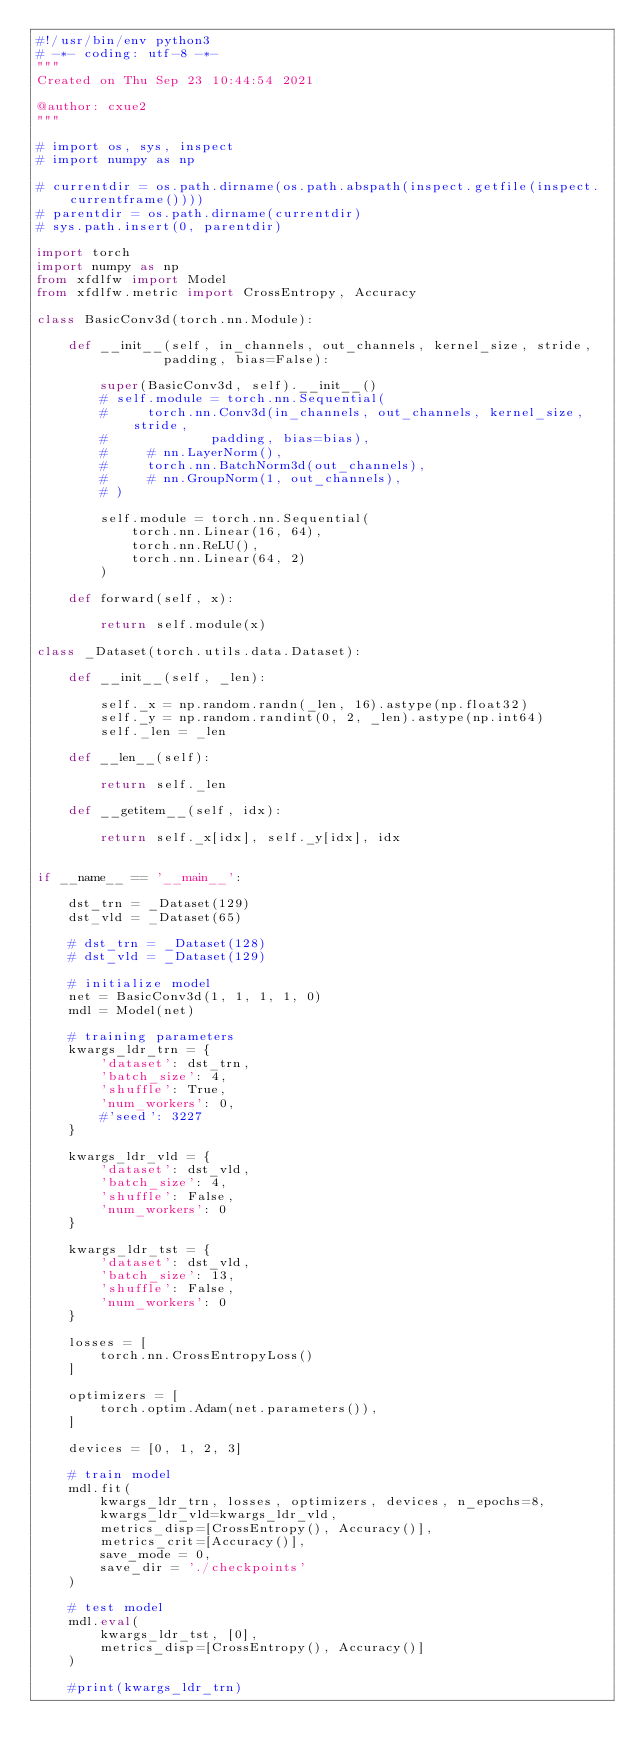<code> <loc_0><loc_0><loc_500><loc_500><_Python_>#!/usr/bin/env python3
# -*- coding: utf-8 -*-
"""
Created on Thu Sep 23 10:44:54 2021

@author: cxue2
"""

# import os, sys, inspect
# import numpy as np

# currentdir = os.path.dirname(os.path.abspath(inspect.getfile(inspect.currentframe())))
# parentdir = os.path.dirname(currentdir)
# sys.path.insert(0, parentdir) 

import torch
import numpy as np
from xfdlfw import Model
from xfdlfw.metric import CrossEntropy, Accuracy

class BasicConv3d(torch.nn.Module):
    
    def __init__(self, in_channels, out_channels, kernel_size, stride,
                padding, bias=False):
        
        super(BasicConv3d, self).__init__()
        # self.module = torch.nn.Sequential(
        #     torch.nn.Conv3d(in_channels, out_channels, kernel_size, stride,
        #             padding, bias=bias),
        #     # nn.LayerNorm(),
        #     torch.nn.BatchNorm3d(out_channels),
        #     # nn.GroupNorm(1, out_channels),
        # )

        self.module = torch.nn.Sequential(
            torch.nn.Linear(16, 64),
            torch.nn.ReLU(),
            torch.nn.Linear(64, 2)
        )

    def forward(self, x):
        
        return self.module(x)

class _Dataset(torch.utils.data.Dataset):

    def __init__(self, _len):

        self._x = np.random.randn(_len, 16).astype(np.float32)
        self._y = np.random.randint(0, 2, _len).astype(np.int64)
        self._len = _len

    def __len__(self): 
        
        return self._len

    def __getitem__(self, idx):
        
        return self._x[idx], self._y[idx], idx


if __name__ == '__main__': 
    
    dst_trn = _Dataset(129)
    dst_vld = _Dataset(65)

    # dst_trn = _Dataset(128)
    # dst_vld = _Dataset(129)
    
    # initialize model
    net = BasicConv3d(1, 1, 1, 1, 0)
    mdl = Model(net)
    
    # training parameters
    kwargs_ldr_trn = {
        'dataset': dst_trn,
        'batch_size': 4,
        'shuffle': True,
        'num_workers': 0,
        #'seed': 3227
    }
    
    kwargs_ldr_vld = {
        'dataset': dst_vld,
        'batch_size': 4,
        'shuffle': False,
        'num_workers': 0
    }

    kwargs_ldr_tst = {
        'dataset': dst_vld,
        'batch_size': 13,
        'shuffle': False,
        'num_workers': 0
    }
    
    losses = [
        torch.nn.CrossEntropyLoss()
    ]

    optimizers = [
        torch.optim.Adam(net.parameters()),
    ]

    devices = [0, 1, 2, 3]
    
    # train model
    mdl.fit(
        kwargs_ldr_trn, losses, optimizers, devices, n_epochs=8,
        kwargs_ldr_vld=kwargs_ldr_vld,
        metrics_disp=[CrossEntropy(), Accuracy()],
        metrics_crit=[Accuracy()],
        save_mode = 0,
        save_dir = './checkpoints'
    )

    # test model
    mdl.eval(
        kwargs_ldr_tst, [0],
        metrics_disp=[CrossEntropy(), Accuracy()]
    )

    #print(kwargs_ldr_trn)
    </code> 